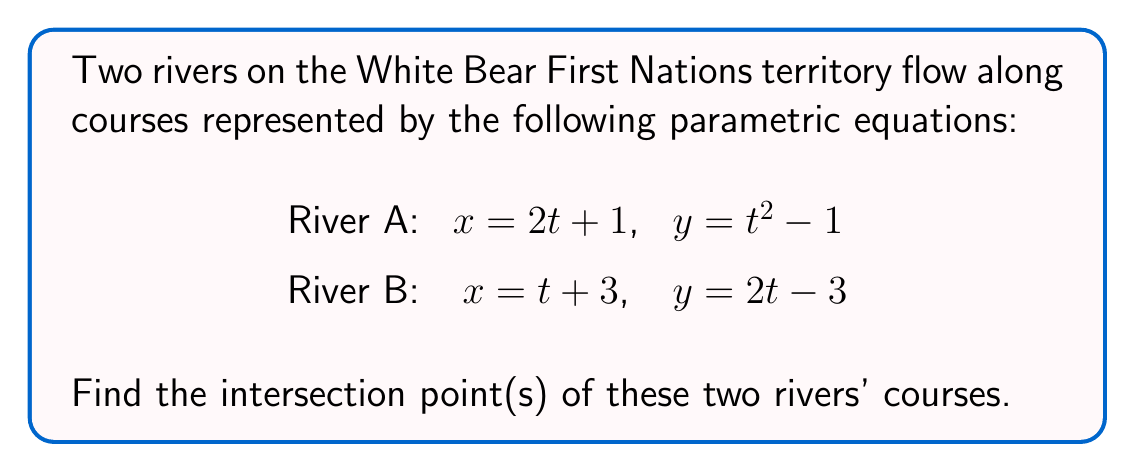Show me your answer to this math problem. To find the intersection points of the two rivers' courses, we need to solve the system of equations formed by equating the x and y components of both parametric equations:

1) First, let's equate the x-components:
   $2t + 1 = t + 3$
   Solving this equation:
   $t = 2$

2) Now, we need to check if this t-value satisfies the y-components as well:
   For River A: $y = t^2 - 1 = 2^2 - 1 = 3$
   For River B: $y = 2t - 3 = 2(2) - 3 = 1$

3) Since the y-values are not equal, $t = 2$ is not a solution. This means we need to solve the system of equations:

   $2t + 1 = t + 3$
   $t^2 - 1 = 2t - 3$

4) From the first equation:
   $t = 2$

5) Substituting this into the second equation:
   $2^2 - 1 = 2(2) - 3$
   $4 - 1 = 4 - 3$
   $3 = 1$

6) This is a contradiction, which means there is no real solution to this system of equations.

Therefore, the two rivers' courses do not intersect at any point.
Answer: The two rivers' courses do not intersect. 